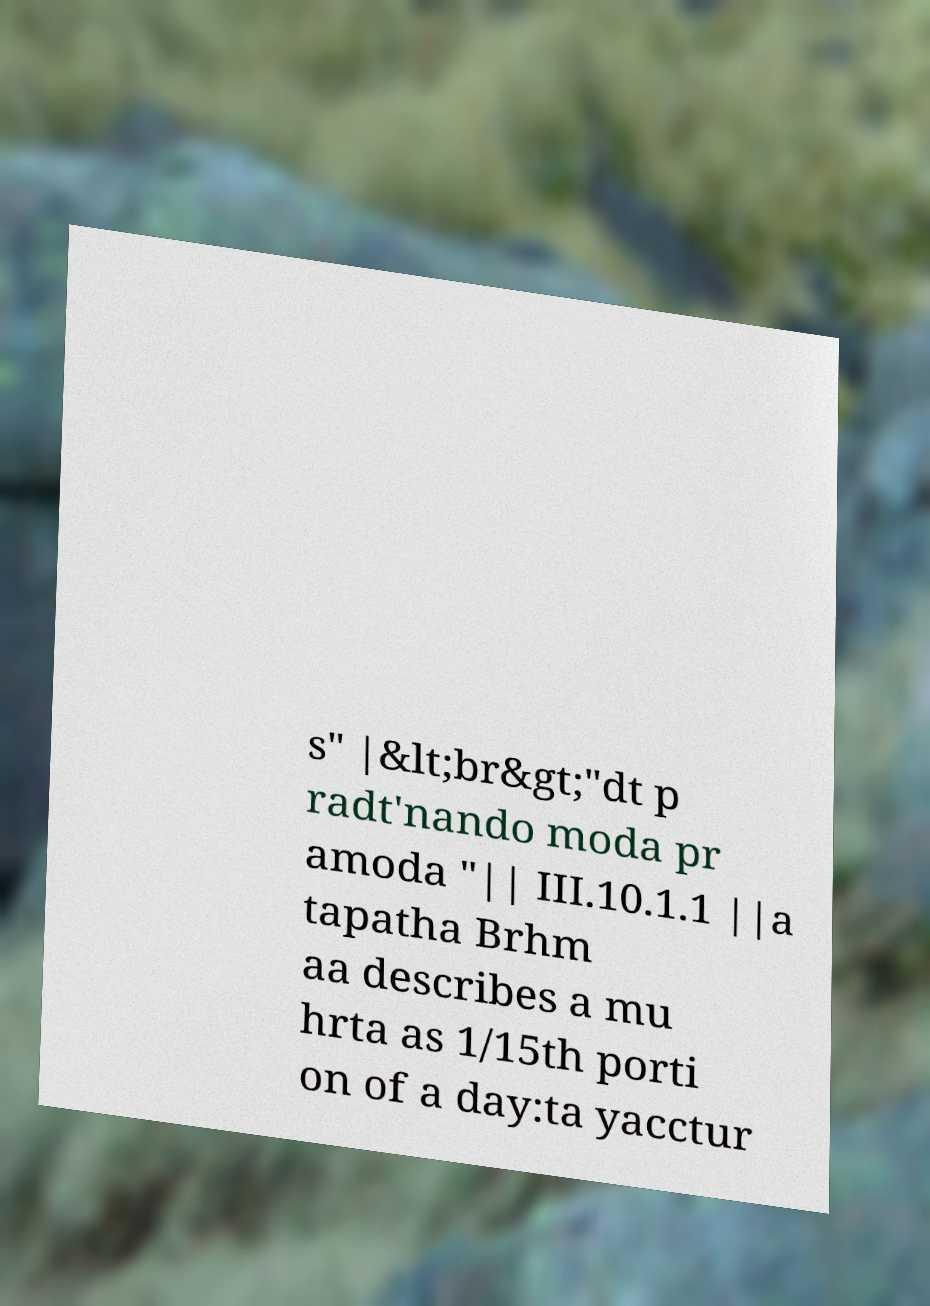Could you extract and type out the text from this image? s" |&lt;br&gt;"dt p radt'nando moda pr amoda "|| III.10.1.1 ||a tapatha Brhm aa describes a mu hrta as 1/15th porti on of a day:ta yacctur 